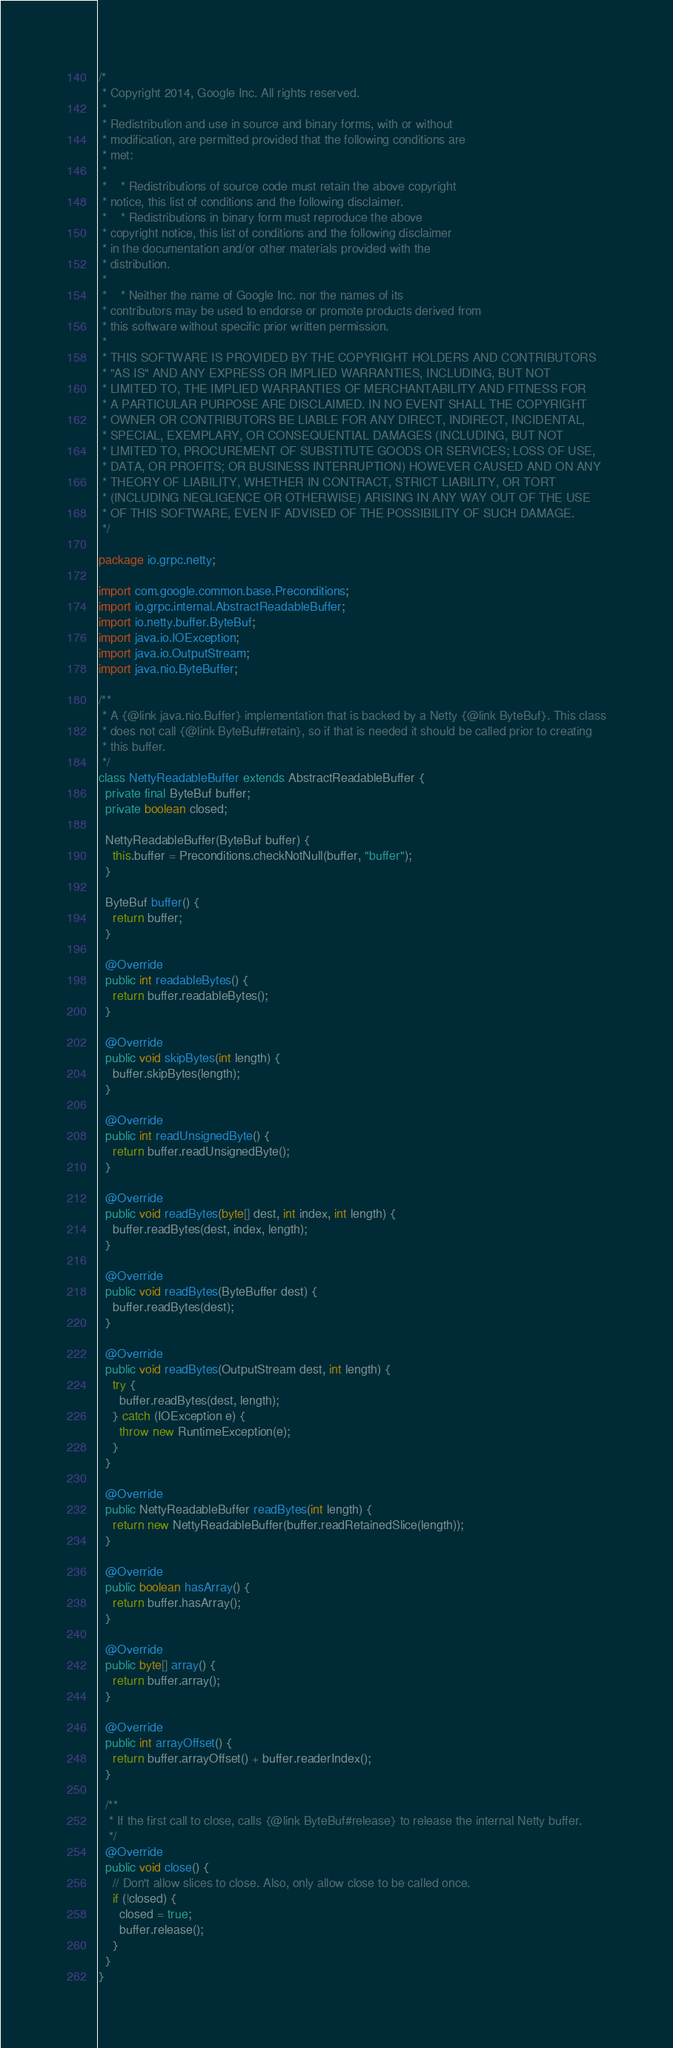<code> <loc_0><loc_0><loc_500><loc_500><_Java_>/*
 * Copyright 2014, Google Inc. All rights reserved.
 *
 * Redistribution and use in source and binary forms, with or without
 * modification, are permitted provided that the following conditions are
 * met:
 *
 *    * Redistributions of source code must retain the above copyright
 * notice, this list of conditions and the following disclaimer.
 *    * Redistributions in binary form must reproduce the above
 * copyright notice, this list of conditions and the following disclaimer
 * in the documentation and/or other materials provided with the
 * distribution.
 *
 *    * Neither the name of Google Inc. nor the names of its
 * contributors may be used to endorse or promote products derived from
 * this software without specific prior written permission.
 *
 * THIS SOFTWARE IS PROVIDED BY THE COPYRIGHT HOLDERS AND CONTRIBUTORS
 * "AS IS" AND ANY EXPRESS OR IMPLIED WARRANTIES, INCLUDING, BUT NOT
 * LIMITED TO, THE IMPLIED WARRANTIES OF MERCHANTABILITY AND FITNESS FOR
 * A PARTICULAR PURPOSE ARE DISCLAIMED. IN NO EVENT SHALL THE COPYRIGHT
 * OWNER OR CONTRIBUTORS BE LIABLE FOR ANY DIRECT, INDIRECT, INCIDENTAL,
 * SPECIAL, EXEMPLARY, OR CONSEQUENTIAL DAMAGES (INCLUDING, BUT NOT
 * LIMITED TO, PROCUREMENT OF SUBSTITUTE GOODS OR SERVICES; LOSS OF USE,
 * DATA, OR PROFITS; OR BUSINESS INTERRUPTION) HOWEVER CAUSED AND ON ANY
 * THEORY OF LIABILITY, WHETHER IN CONTRACT, STRICT LIABILITY, OR TORT
 * (INCLUDING NEGLIGENCE OR OTHERWISE) ARISING IN ANY WAY OUT OF THE USE
 * OF THIS SOFTWARE, EVEN IF ADVISED OF THE POSSIBILITY OF SUCH DAMAGE.
 */

package io.grpc.netty;

import com.google.common.base.Preconditions;
import io.grpc.internal.AbstractReadableBuffer;
import io.netty.buffer.ByteBuf;
import java.io.IOException;
import java.io.OutputStream;
import java.nio.ByteBuffer;

/**
 * A {@link java.nio.Buffer} implementation that is backed by a Netty {@link ByteBuf}. This class
 * does not call {@link ByteBuf#retain}, so if that is needed it should be called prior to creating
 * this buffer.
 */
class NettyReadableBuffer extends AbstractReadableBuffer {
  private final ByteBuf buffer;
  private boolean closed;

  NettyReadableBuffer(ByteBuf buffer) {
    this.buffer = Preconditions.checkNotNull(buffer, "buffer");
  }

  ByteBuf buffer() {
    return buffer;
  }

  @Override
  public int readableBytes() {
    return buffer.readableBytes();
  }

  @Override
  public void skipBytes(int length) {
    buffer.skipBytes(length);
  }

  @Override
  public int readUnsignedByte() {
    return buffer.readUnsignedByte();
  }

  @Override
  public void readBytes(byte[] dest, int index, int length) {
    buffer.readBytes(dest, index, length);
  }

  @Override
  public void readBytes(ByteBuffer dest) {
    buffer.readBytes(dest);
  }

  @Override
  public void readBytes(OutputStream dest, int length) {
    try {
      buffer.readBytes(dest, length);
    } catch (IOException e) {
      throw new RuntimeException(e);
    }
  }

  @Override
  public NettyReadableBuffer readBytes(int length) {
    return new NettyReadableBuffer(buffer.readRetainedSlice(length));
  }

  @Override
  public boolean hasArray() {
    return buffer.hasArray();
  }

  @Override
  public byte[] array() {
    return buffer.array();
  }

  @Override
  public int arrayOffset() {
    return buffer.arrayOffset() + buffer.readerIndex();
  }

  /**
   * If the first call to close, calls {@link ByteBuf#release} to release the internal Netty buffer.
   */
  @Override
  public void close() {
    // Don't allow slices to close. Also, only allow close to be called once.
    if (!closed) {
      closed = true;
      buffer.release();
    }
  }
}
</code> 